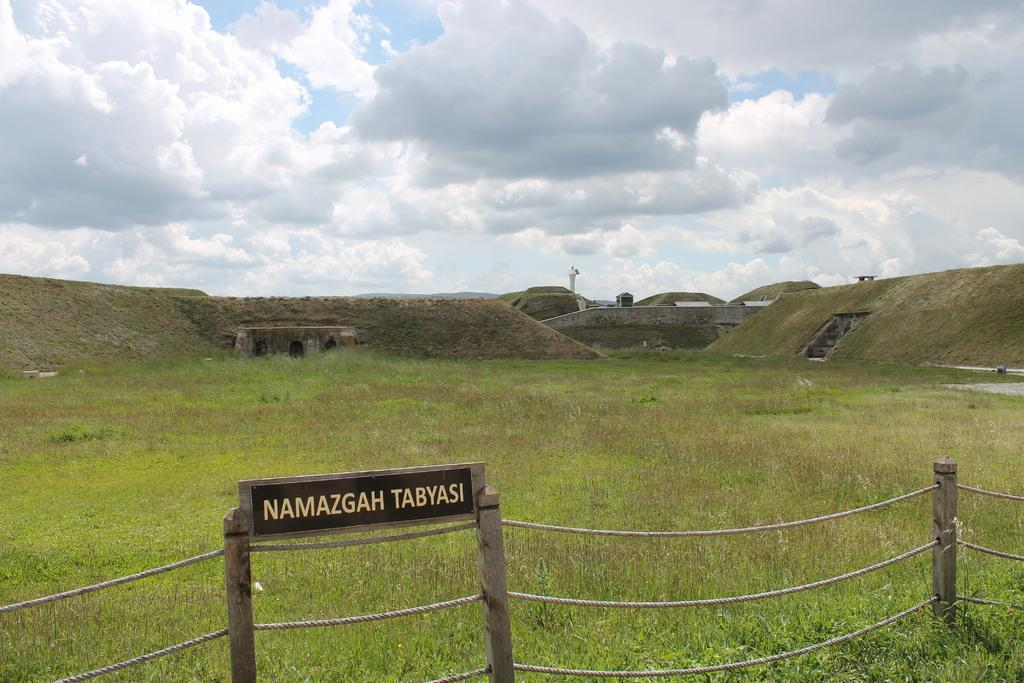What type of vegetation can be seen in the image? There is grass in the image. What type of barrier is present in the image? There is a fence in the image. What is written or displayed on a board in the image? There is a board with text in the image. What type of structure is visible in the image? There is a constructed area with a wall in the image. What is the tall, vertical object in the image? There is a pole in the image. What is visible at the top of the image? The sky is visible at the top of the image. How many kittens are playing with the pole in the image? There are no kittens present in the image; it features a pole and other elements mentioned in the facts. What advice does the father give to the person in the image? There is no father or person present in the image, as it only contains the mentioned elements. 